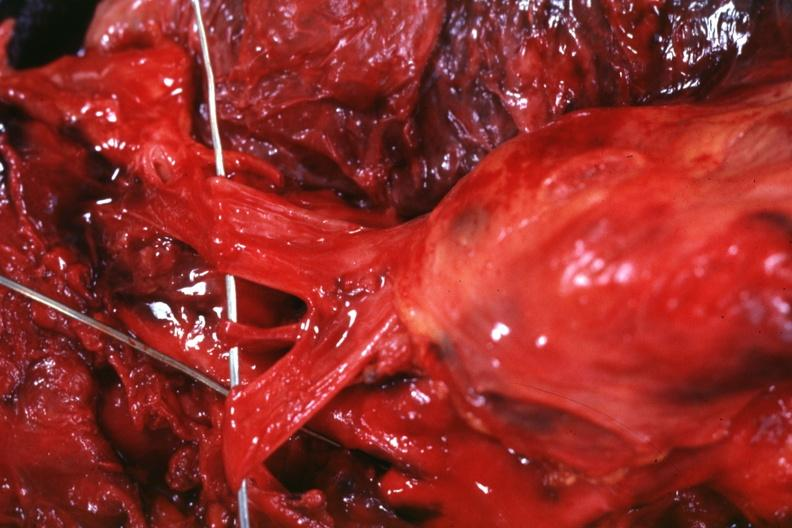s malignant thymoma present?
Answer the question using a single word or phrase. Yes 